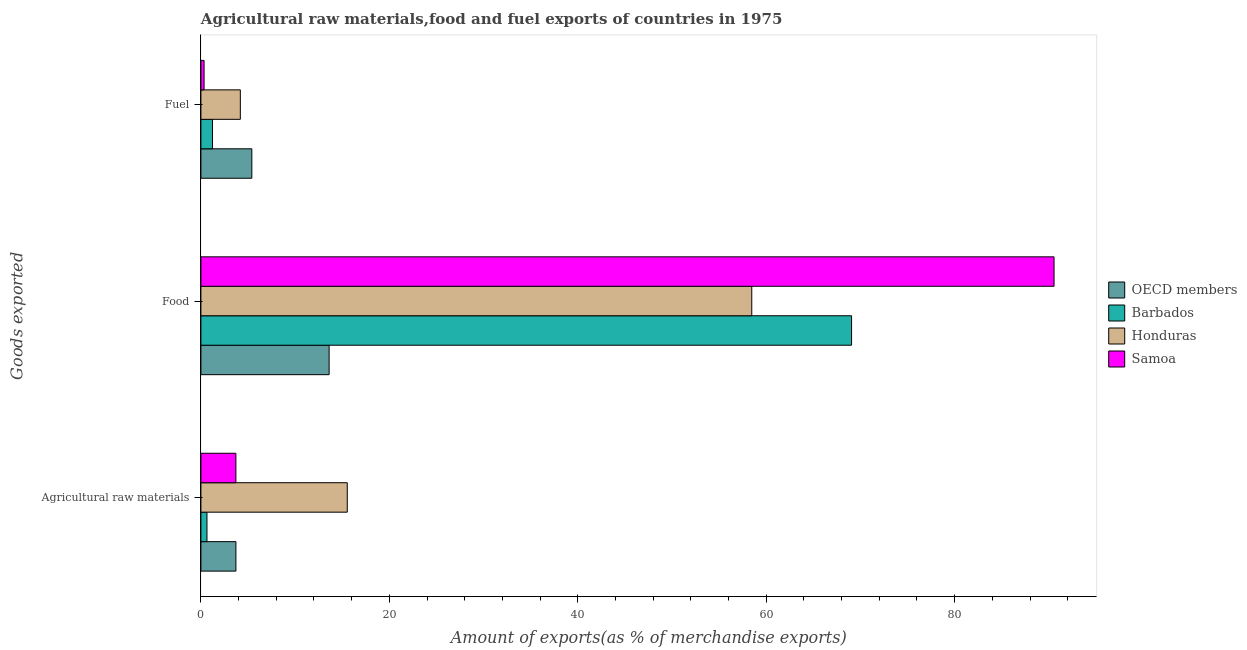Are the number of bars on each tick of the Y-axis equal?
Your answer should be compact. Yes. How many bars are there on the 2nd tick from the bottom?
Provide a succinct answer. 4. What is the label of the 3rd group of bars from the top?
Offer a terse response. Agricultural raw materials. What is the percentage of food exports in Barbados?
Your answer should be very brief. 69.06. Across all countries, what is the maximum percentage of food exports?
Your response must be concise. 90.55. Across all countries, what is the minimum percentage of food exports?
Provide a succinct answer. 13.61. In which country was the percentage of raw materials exports minimum?
Your response must be concise. Barbados. What is the total percentage of food exports in the graph?
Keep it short and to the point. 231.68. What is the difference between the percentage of fuel exports in OECD members and that in Barbados?
Give a very brief answer. 4.17. What is the difference between the percentage of fuel exports in Samoa and the percentage of food exports in OECD members?
Ensure brevity in your answer.  -13.27. What is the average percentage of raw materials exports per country?
Give a very brief answer. 5.9. What is the difference between the percentage of fuel exports and percentage of raw materials exports in Honduras?
Give a very brief answer. -11.35. What is the ratio of the percentage of food exports in OECD members to that in Samoa?
Offer a terse response. 0.15. Is the percentage of raw materials exports in Barbados less than that in Samoa?
Keep it short and to the point. Yes. Is the difference between the percentage of raw materials exports in OECD members and Honduras greater than the difference between the percentage of fuel exports in OECD members and Honduras?
Your answer should be compact. No. What is the difference between the highest and the second highest percentage of raw materials exports?
Provide a short and direct response. 11.82. What is the difference between the highest and the lowest percentage of food exports?
Your answer should be compact. 76.94. Is the sum of the percentage of food exports in Honduras and Samoa greater than the maximum percentage of fuel exports across all countries?
Your answer should be compact. Yes. What does the 4th bar from the top in Fuel represents?
Keep it short and to the point. OECD members. Is it the case that in every country, the sum of the percentage of raw materials exports and percentage of food exports is greater than the percentage of fuel exports?
Give a very brief answer. Yes. Are all the bars in the graph horizontal?
Give a very brief answer. Yes. How many countries are there in the graph?
Offer a very short reply. 4. What is the difference between two consecutive major ticks on the X-axis?
Offer a very short reply. 20. Are the values on the major ticks of X-axis written in scientific E-notation?
Your answer should be compact. No. What is the title of the graph?
Ensure brevity in your answer.  Agricultural raw materials,food and fuel exports of countries in 1975. Does "Europe(developing only)" appear as one of the legend labels in the graph?
Give a very brief answer. No. What is the label or title of the X-axis?
Offer a terse response. Amount of exports(as % of merchandise exports). What is the label or title of the Y-axis?
Give a very brief answer. Goods exported. What is the Amount of exports(as % of merchandise exports) of OECD members in Agricultural raw materials?
Your answer should be very brief. 3.72. What is the Amount of exports(as % of merchandise exports) in Barbados in Agricultural raw materials?
Your answer should be compact. 0.64. What is the Amount of exports(as % of merchandise exports) of Honduras in Agricultural raw materials?
Make the answer very short. 15.53. What is the Amount of exports(as % of merchandise exports) in Samoa in Agricultural raw materials?
Your response must be concise. 3.71. What is the Amount of exports(as % of merchandise exports) of OECD members in Food?
Your answer should be very brief. 13.61. What is the Amount of exports(as % of merchandise exports) of Barbados in Food?
Keep it short and to the point. 69.06. What is the Amount of exports(as % of merchandise exports) of Honduras in Food?
Offer a very short reply. 58.47. What is the Amount of exports(as % of merchandise exports) of Samoa in Food?
Provide a succinct answer. 90.55. What is the Amount of exports(as % of merchandise exports) in OECD members in Fuel?
Provide a short and direct response. 5.4. What is the Amount of exports(as % of merchandise exports) of Barbados in Fuel?
Provide a succinct answer. 1.23. What is the Amount of exports(as % of merchandise exports) of Honduras in Fuel?
Give a very brief answer. 4.18. What is the Amount of exports(as % of merchandise exports) of Samoa in Fuel?
Provide a succinct answer. 0.34. Across all Goods exported, what is the maximum Amount of exports(as % of merchandise exports) in OECD members?
Your response must be concise. 13.61. Across all Goods exported, what is the maximum Amount of exports(as % of merchandise exports) in Barbados?
Offer a terse response. 69.06. Across all Goods exported, what is the maximum Amount of exports(as % of merchandise exports) in Honduras?
Your answer should be very brief. 58.47. Across all Goods exported, what is the maximum Amount of exports(as % of merchandise exports) of Samoa?
Keep it short and to the point. 90.55. Across all Goods exported, what is the minimum Amount of exports(as % of merchandise exports) in OECD members?
Provide a short and direct response. 3.72. Across all Goods exported, what is the minimum Amount of exports(as % of merchandise exports) in Barbados?
Offer a terse response. 0.64. Across all Goods exported, what is the minimum Amount of exports(as % of merchandise exports) in Honduras?
Your answer should be compact. 4.18. Across all Goods exported, what is the minimum Amount of exports(as % of merchandise exports) of Samoa?
Offer a very short reply. 0.34. What is the total Amount of exports(as % of merchandise exports) of OECD members in the graph?
Keep it short and to the point. 22.73. What is the total Amount of exports(as % of merchandise exports) of Barbados in the graph?
Provide a succinct answer. 70.93. What is the total Amount of exports(as % of merchandise exports) of Honduras in the graph?
Make the answer very short. 78.18. What is the total Amount of exports(as % of merchandise exports) in Samoa in the graph?
Provide a short and direct response. 94.6. What is the difference between the Amount of exports(as % of merchandise exports) of OECD members in Agricultural raw materials and that in Food?
Your answer should be very brief. -9.89. What is the difference between the Amount of exports(as % of merchandise exports) of Barbados in Agricultural raw materials and that in Food?
Make the answer very short. -68.42. What is the difference between the Amount of exports(as % of merchandise exports) in Honduras in Agricultural raw materials and that in Food?
Your answer should be very brief. -42.93. What is the difference between the Amount of exports(as % of merchandise exports) in Samoa in Agricultural raw materials and that in Food?
Ensure brevity in your answer.  -86.83. What is the difference between the Amount of exports(as % of merchandise exports) in OECD members in Agricultural raw materials and that in Fuel?
Provide a succinct answer. -1.69. What is the difference between the Amount of exports(as % of merchandise exports) in Barbados in Agricultural raw materials and that in Fuel?
Your answer should be very brief. -0.59. What is the difference between the Amount of exports(as % of merchandise exports) in Honduras in Agricultural raw materials and that in Fuel?
Give a very brief answer. 11.35. What is the difference between the Amount of exports(as % of merchandise exports) of Samoa in Agricultural raw materials and that in Fuel?
Your response must be concise. 3.38. What is the difference between the Amount of exports(as % of merchandise exports) in OECD members in Food and that in Fuel?
Give a very brief answer. 8.2. What is the difference between the Amount of exports(as % of merchandise exports) of Barbados in Food and that in Fuel?
Provide a succinct answer. 67.83. What is the difference between the Amount of exports(as % of merchandise exports) of Honduras in Food and that in Fuel?
Provide a short and direct response. 54.28. What is the difference between the Amount of exports(as % of merchandise exports) of Samoa in Food and that in Fuel?
Provide a short and direct response. 90.21. What is the difference between the Amount of exports(as % of merchandise exports) in OECD members in Agricultural raw materials and the Amount of exports(as % of merchandise exports) in Barbados in Food?
Give a very brief answer. -65.34. What is the difference between the Amount of exports(as % of merchandise exports) in OECD members in Agricultural raw materials and the Amount of exports(as % of merchandise exports) in Honduras in Food?
Offer a very short reply. -54.75. What is the difference between the Amount of exports(as % of merchandise exports) in OECD members in Agricultural raw materials and the Amount of exports(as % of merchandise exports) in Samoa in Food?
Your answer should be compact. -86.83. What is the difference between the Amount of exports(as % of merchandise exports) of Barbados in Agricultural raw materials and the Amount of exports(as % of merchandise exports) of Honduras in Food?
Offer a terse response. -57.82. What is the difference between the Amount of exports(as % of merchandise exports) of Barbados in Agricultural raw materials and the Amount of exports(as % of merchandise exports) of Samoa in Food?
Your answer should be compact. -89.91. What is the difference between the Amount of exports(as % of merchandise exports) of Honduras in Agricultural raw materials and the Amount of exports(as % of merchandise exports) of Samoa in Food?
Give a very brief answer. -75.01. What is the difference between the Amount of exports(as % of merchandise exports) of OECD members in Agricultural raw materials and the Amount of exports(as % of merchandise exports) of Barbados in Fuel?
Give a very brief answer. 2.48. What is the difference between the Amount of exports(as % of merchandise exports) in OECD members in Agricultural raw materials and the Amount of exports(as % of merchandise exports) in Honduras in Fuel?
Offer a very short reply. -0.47. What is the difference between the Amount of exports(as % of merchandise exports) in OECD members in Agricultural raw materials and the Amount of exports(as % of merchandise exports) in Samoa in Fuel?
Offer a terse response. 3.38. What is the difference between the Amount of exports(as % of merchandise exports) of Barbados in Agricultural raw materials and the Amount of exports(as % of merchandise exports) of Honduras in Fuel?
Ensure brevity in your answer.  -3.54. What is the difference between the Amount of exports(as % of merchandise exports) in Barbados in Agricultural raw materials and the Amount of exports(as % of merchandise exports) in Samoa in Fuel?
Offer a terse response. 0.31. What is the difference between the Amount of exports(as % of merchandise exports) of Honduras in Agricultural raw materials and the Amount of exports(as % of merchandise exports) of Samoa in Fuel?
Give a very brief answer. 15.2. What is the difference between the Amount of exports(as % of merchandise exports) of OECD members in Food and the Amount of exports(as % of merchandise exports) of Barbados in Fuel?
Keep it short and to the point. 12.38. What is the difference between the Amount of exports(as % of merchandise exports) in OECD members in Food and the Amount of exports(as % of merchandise exports) in Honduras in Fuel?
Offer a terse response. 9.42. What is the difference between the Amount of exports(as % of merchandise exports) in OECD members in Food and the Amount of exports(as % of merchandise exports) in Samoa in Fuel?
Offer a very short reply. 13.27. What is the difference between the Amount of exports(as % of merchandise exports) of Barbados in Food and the Amount of exports(as % of merchandise exports) of Honduras in Fuel?
Offer a very short reply. 64.88. What is the difference between the Amount of exports(as % of merchandise exports) in Barbados in Food and the Amount of exports(as % of merchandise exports) in Samoa in Fuel?
Ensure brevity in your answer.  68.72. What is the difference between the Amount of exports(as % of merchandise exports) in Honduras in Food and the Amount of exports(as % of merchandise exports) in Samoa in Fuel?
Provide a succinct answer. 58.13. What is the average Amount of exports(as % of merchandise exports) of OECD members per Goods exported?
Give a very brief answer. 7.58. What is the average Amount of exports(as % of merchandise exports) in Barbados per Goods exported?
Your answer should be very brief. 23.64. What is the average Amount of exports(as % of merchandise exports) in Honduras per Goods exported?
Provide a succinct answer. 26.06. What is the average Amount of exports(as % of merchandise exports) of Samoa per Goods exported?
Your answer should be compact. 31.53. What is the difference between the Amount of exports(as % of merchandise exports) in OECD members and Amount of exports(as % of merchandise exports) in Barbados in Agricultural raw materials?
Offer a terse response. 3.07. What is the difference between the Amount of exports(as % of merchandise exports) in OECD members and Amount of exports(as % of merchandise exports) in Honduras in Agricultural raw materials?
Your answer should be very brief. -11.82. What is the difference between the Amount of exports(as % of merchandise exports) of OECD members and Amount of exports(as % of merchandise exports) of Samoa in Agricultural raw materials?
Give a very brief answer. 0. What is the difference between the Amount of exports(as % of merchandise exports) of Barbados and Amount of exports(as % of merchandise exports) of Honduras in Agricultural raw materials?
Ensure brevity in your answer.  -14.89. What is the difference between the Amount of exports(as % of merchandise exports) in Barbados and Amount of exports(as % of merchandise exports) in Samoa in Agricultural raw materials?
Offer a terse response. -3.07. What is the difference between the Amount of exports(as % of merchandise exports) of Honduras and Amount of exports(as % of merchandise exports) of Samoa in Agricultural raw materials?
Ensure brevity in your answer.  11.82. What is the difference between the Amount of exports(as % of merchandise exports) of OECD members and Amount of exports(as % of merchandise exports) of Barbados in Food?
Make the answer very short. -55.45. What is the difference between the Amount of exports(as % of merchandise exports) in OECD members and Amount of exports(as % of merchandise exports) in Honduras in Food?
Make the answer very short. -44.86. What is the difference between the Amount of exports(as % of merchandise exports) of OECD members and Amount of exports(as % of merchandise exports) of Samoa in Food?
Offer a very short reply. -76.94. What is the difference between the Amount of exports(as % of merchandise exports) of Barbados and Amount of exports(as % of merchandise exports) of Honduras in Food?
Offer a terse response. 10.59. What is the difference between the Amount of exports(as % of merchandise exports) in Barbados and Amount of exports(as % of merchandise exports) in Samoa in Food?
Provide a succinct answer. -21.49. What is the difference between the Amount of exports(as % of merchandise exports) in Honduras and Amount of exports(as % of merchandise exports) in Samoa in Food?
Your response must be concise. -32.08. What is the difference between the Amount of exports(as % of merchandise exports) in OECD members and Amount of exports(as % of merchandise exports) in Barbados in Fuel?
Your response must be concise. 4.17. What is the difference between the Amount of exports(as % of merchandise exports) in OECD members and Amount of exports(as % of merchandise exports) in Honduras in Fuel?
Provide a succinct answer. 1.22. What is the difference between the Amount of exports(as % of merchandise exports) of OECD members and Amount of exports(as % of merchandise exports) of Samoa in Fuel?
Your response must be concise. 5.07. What is the difference between the Amount of exports(as % of merchandise exports) of Barbados and Amount of exports(as % of merchandise exports) of Honduras in Fuel?
Your answer should be compact. -2.95. What is the difference between the Amount of exports(as % of merchandise exports) in Barbados and Amount of exports(as % of merchandise exports) in Samoa in Fuel?
Provide a short and direct response. 0.9. What is the difference between the Amount of exports(as % of merchandise exports) of Honduras and Amount of exports(as % of merchandise exports) of Samoa in Fuel?
Give a very brief answer. 3.85. What is the ratio of the Amount of exports(as % of merchandise exports) in OECD members in Agricultural raw materials to that in Food?
Provide a succinct answer. 0.27. What is the ratio of the Amount of exports(as % of merchandise exports) of Barbados in Agricultural raw materials to that in Food?
Offer a terse response. 0.01. What is the ratio of the Amount of exports(as % of merchandise exports) in Honduras in Agricultural raw materials to that in Food?
Provide a succinct answer. 0.27. What is the ratio of the Amount of exports(as % of merchandise exports) of Samoa in Agricultural raw materials to that in Food?
Provide a succinct answer. 0.04. What is the ratio of the Amount of exports(as % of merchandise exports) of OECD members in Agricultural raw materials to that in Fuel?
Keep it short and to the point. 0.69. What is the ratio of the Amount of exports(as % of merchandise exports) in Barbados in Agricultural raw materials to that in Fuel?
Offer a terse response. 0.52. What is the ratio of the Amount of exports(as % of merchandise exports) of Honduras in Agricultural raw materials to that in Fuel?
Offer a very short reply. 3.71. What is the ratio of the Amount of exports(as % of merchandise exports) in Samoa in Agricultural raw materials to that in Fuel?
Provide a short and direct response. 11.07. What is the ratio of the Amount of exports(as % of merchandise exports) of OECD members in Food to that in Fuel?
Your answer should be very brief. 2.52. What is the ratio of the Amount of exports(as % of merchandise exports) of Barbados in Food to that in Fuel?
Make the answer very short. 56.06. What is the ratio of the Amount of exports(as % of merchandise exports) in Honduras in Food to that in Fuel?
Give a very brief answer. 13.98. What is the ratio of the Amount of exports(as % of merchandise exports) of Samoa in Food to that in Fuel?
Give a very brief answer. 269.99. What is the difference between the highest and the second highest Amount of exports(as % of merchandise exports) in OECD members?
Your answer should be very brief. 8.2. What is the difference between the highest and the second highest Amount of exports(as % of merchandise exports) in Barbados?
Keep it short and to the point. 67.83. What is the difference between the highest and the second highest Amount of exports(as % of merchandise exports) in Honduras?
Offer a terse response. 42.93. What is the difference between the highest and the second highest Amount of exports(as % of merchandise exports) in Samoa?
Offer a very short reply. 86.83. What is the difference between the highest and the lowest Amount of exports(as % of merchandise exports) of OECD members?
Your response must be concise. 9.89. What is the difference between the highest and the lowest Amount of exports(as % of merchandise exports) in Barbados?
Your answer should be very brief. 68.42. What is the difference between the highest and the lowest Amount of exports(as % of merchandise exports) in Honduras?
Provide a succinct answer. 54.28. What is the difference between the highest and the lowest Amount of exports(as % of merchandise exports) of Samoa?
Ensure brevity in your answer.  90.21. 